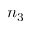Convert formula to latex. <formula><loc_0><loc_0><loc_500><loc_500>n _ { 3 }</formula> 